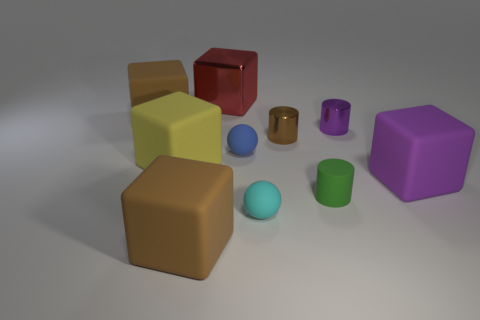Subtract all small rubber cylinders. How many cylinders are left? 2 Subtract all red balls. How many brown cubes are left? 2 Subtract 3 cubes. How many cubes are left? 2 Subtract all yellow cubes. How many cubes are left? 4 Subtract all spheres. How many objects are left? 8 Subtract all gray cubes. Subtract all gray cylinders. How many cubes are left? 5 Subtract all small cyan blocks. Subtract all brown rubber objects. How many objects are left? 8 Add 4 blue things. How many blue things are left? 5 Add 3 big red metallic cubes. How many big red metallic cubes exist? 4 Subtract 1 purple cubes. How many objects are left? 9 